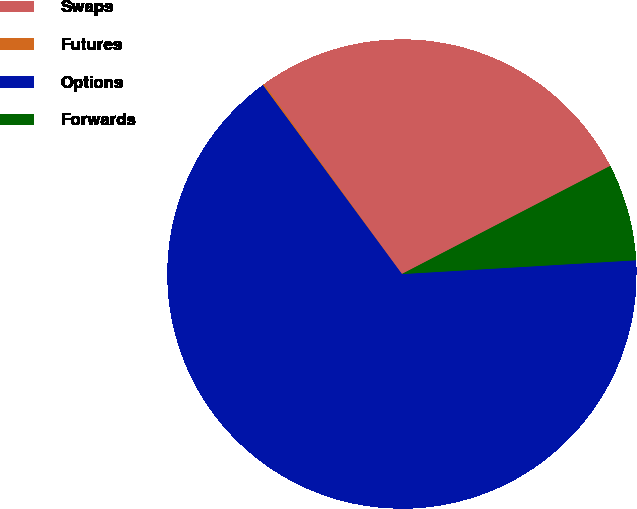Convert chart to OTSL. <chart><loc_0><loc_0><loc_500><loc_500><pie_chart><fcel>Swaps<fcel>Futures<fcel>Options<fcel>Forwards<nl><fcel>27.37%<fcel>0.11%<fcel>65.84%<fcel>6.68%<nl></chart> 